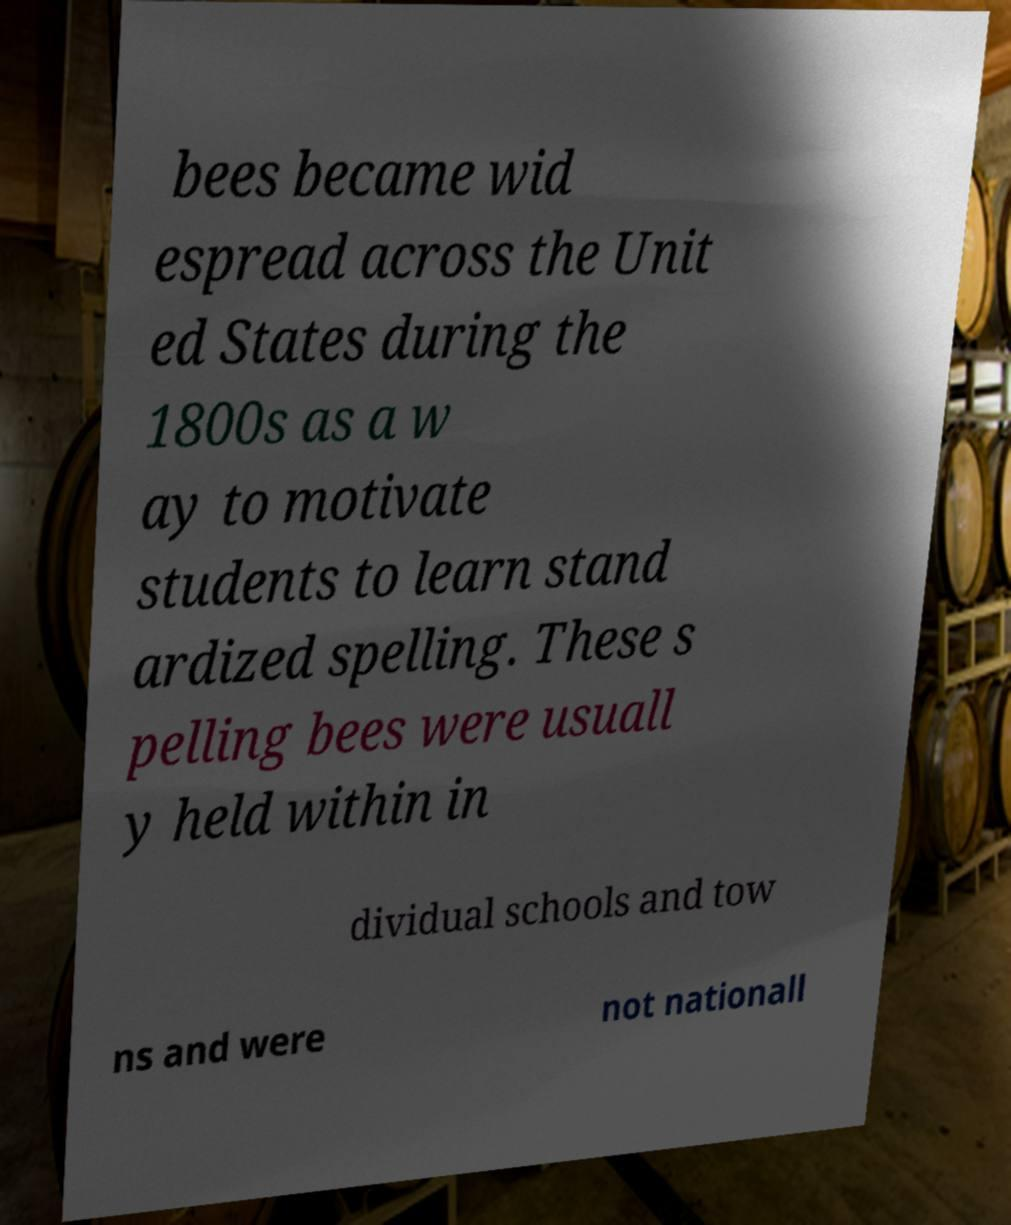Please identify and transcribe the text found in this image. bees became wid espread across the Unit ed States during the 1800s as a w ay to motivate students to learn stand ardized spelling. These s pelling bees were usuall y held within in dividual schools and tow ns and were not nationall 